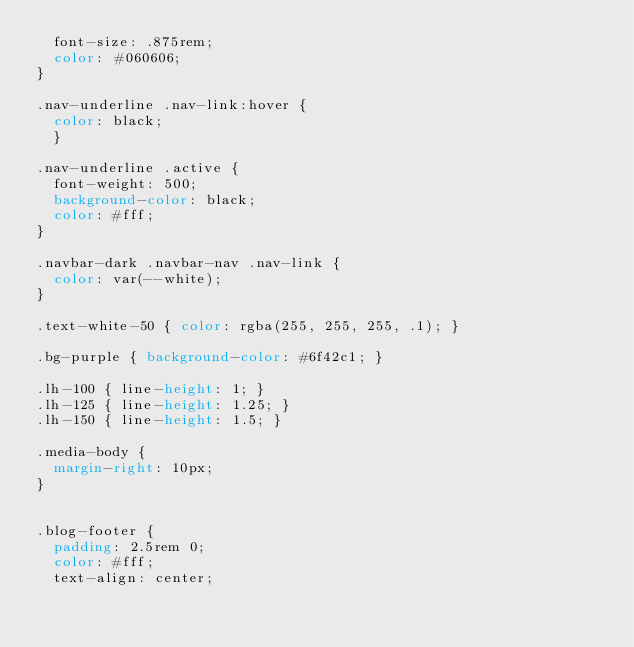Convert code to text. <code><loc_0><loc_0><loc_500><loc_500><_CSS_>  font-size: .875rem;
  color: #060606;
}
 
.nav-underline .nav-link:hover {
  color: black;
  }
 
.nav-underline .active {
  font-weight: 500;
  background-color: black;
  color: #fff;
}

.navbar-dark .navbar-nav .nav-link {
  color: var(--white);
}
 
.text-white-50 { color: rgba(255, 255, 255, .1); }
 
.bg-purple { background-color: #6f42c1; }
 
.lh-100 { line-height: 1; }
.lh-125 { line-height: 1.25; }
.lh-150 { line-height: 1.5; }

.media-body {
  margin-right: 10px;
}


.blog-footer {
  padding: 2.5rem 0;
  color: #fff;
  text-align: center;</code> 